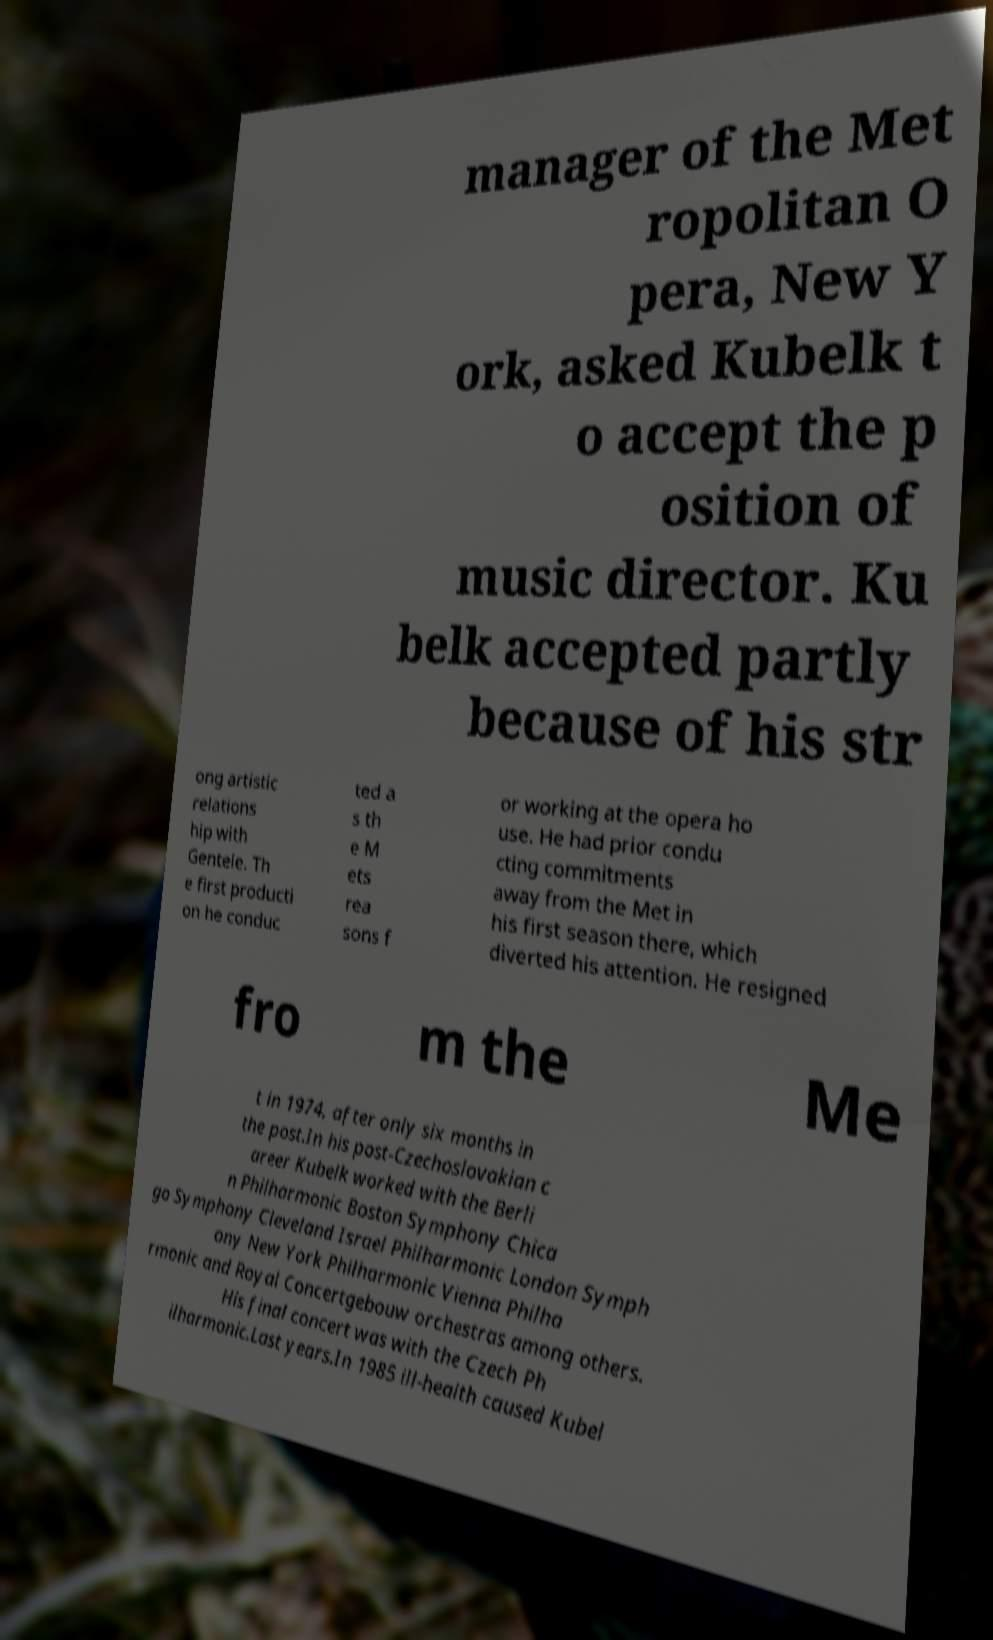There's text embedded in this image that I need extracted. Can you transcribe it verbatim? manager of the Met ropolitan O pera, New Y ork, asked Kubelk t o accept the p osition of music director. Ku belk accepted partly because of his str ong artistic relations hip with Gentele. Th e first producti on he conduc ted a s th e M ets rea sons f or working at the opera ho use. He had prior condu cting commitments away from the Met in his first season there, which diverted his attention. He resigned fro m the Me t in 1974, after only six months in the post.In his post-Czechoslovakian c areer Kubelk worked with the Berli n Philharmonic Boston Symphony Chica go Symphony Cleveland Israel Philharmonic London Symph ony New York Philharmonic Vienna Philha rmonic and Royal Concertgebouw orchestras among others. His final concert was with the Czech Ph ilharmonic.Last years.In 1985 ill-health caused Kubel 